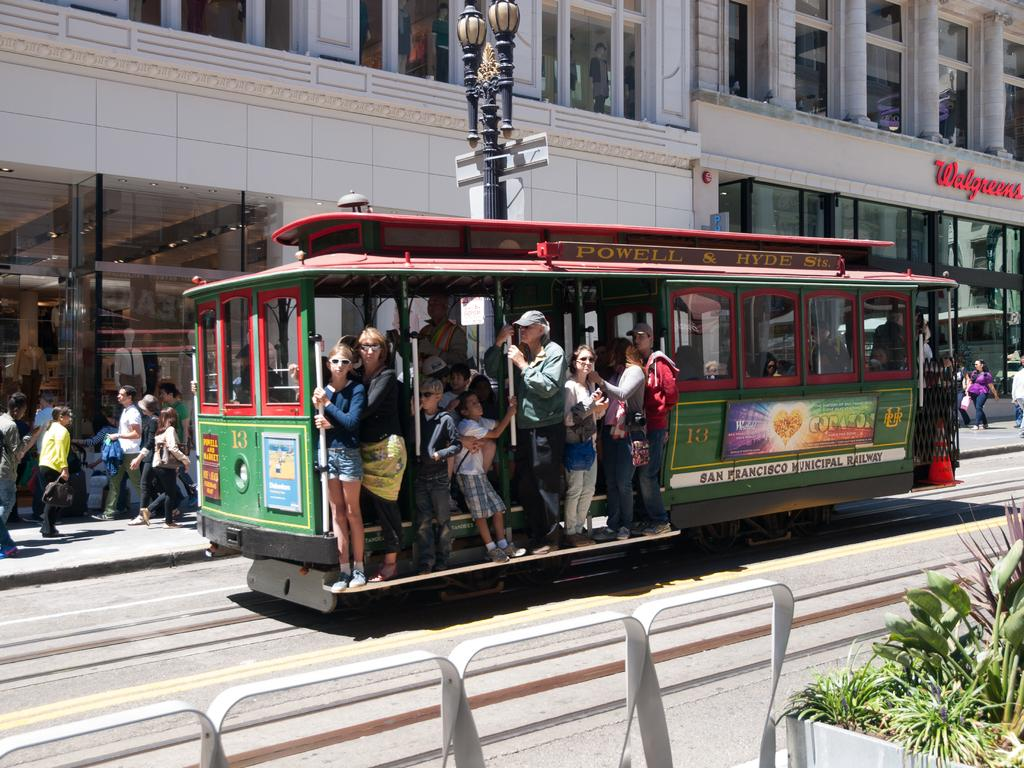<image>
Describe the image concisely. a Walgreens store that is near a train outside 